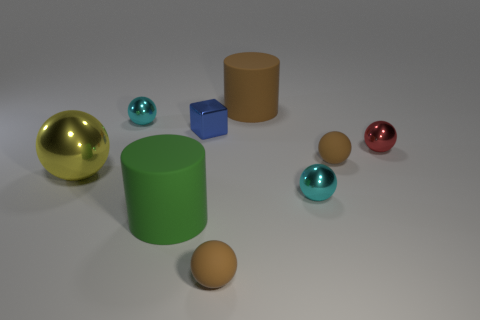Is the large yellow object the same shape as the big green thing?
Keep it short and to the point. No. What is the big green cylinder made of?
Give a very brief answer. Rubber. How many things are both in front of the large ball and on the right side of the metallic cube?
Make the answer very short. 2. Do the red shiny sphere and the yellow metallic ball have the same size?
Give a very brief answer. No. There is a rubber cylinder behind the red shiny thing; does it have the same size as the green rubber thing?
Offer a terse response. Yes. There is a sphere that is in front of the green cylinder; what color is it?
Your answer should be compact. Brown. How many small purple spheres are there?
Provide a succinct answer. 0. There is a yellow object that is made of the same material as the small block; what is its shape?
Offer a terse response. Sphere. There is a matte object right of the big brown thing; does it have the same color as the small matte thing that is in front of the large yellow object?
Provide a succinct answer. Yes. Are there an equal number of large objects that are on the right side of the small shiny block and small red things?
Provide a short and direct response. Yes. 